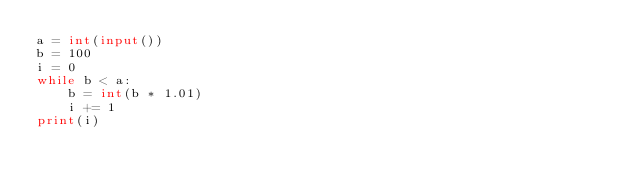<code> <loc_0><loc_0><loc_500><loc_500><_Python_>a = int(input())
b = 100
i = 0
while b < a:
	b = int(b * 1.01)
	i += 1
print(i)</code> 